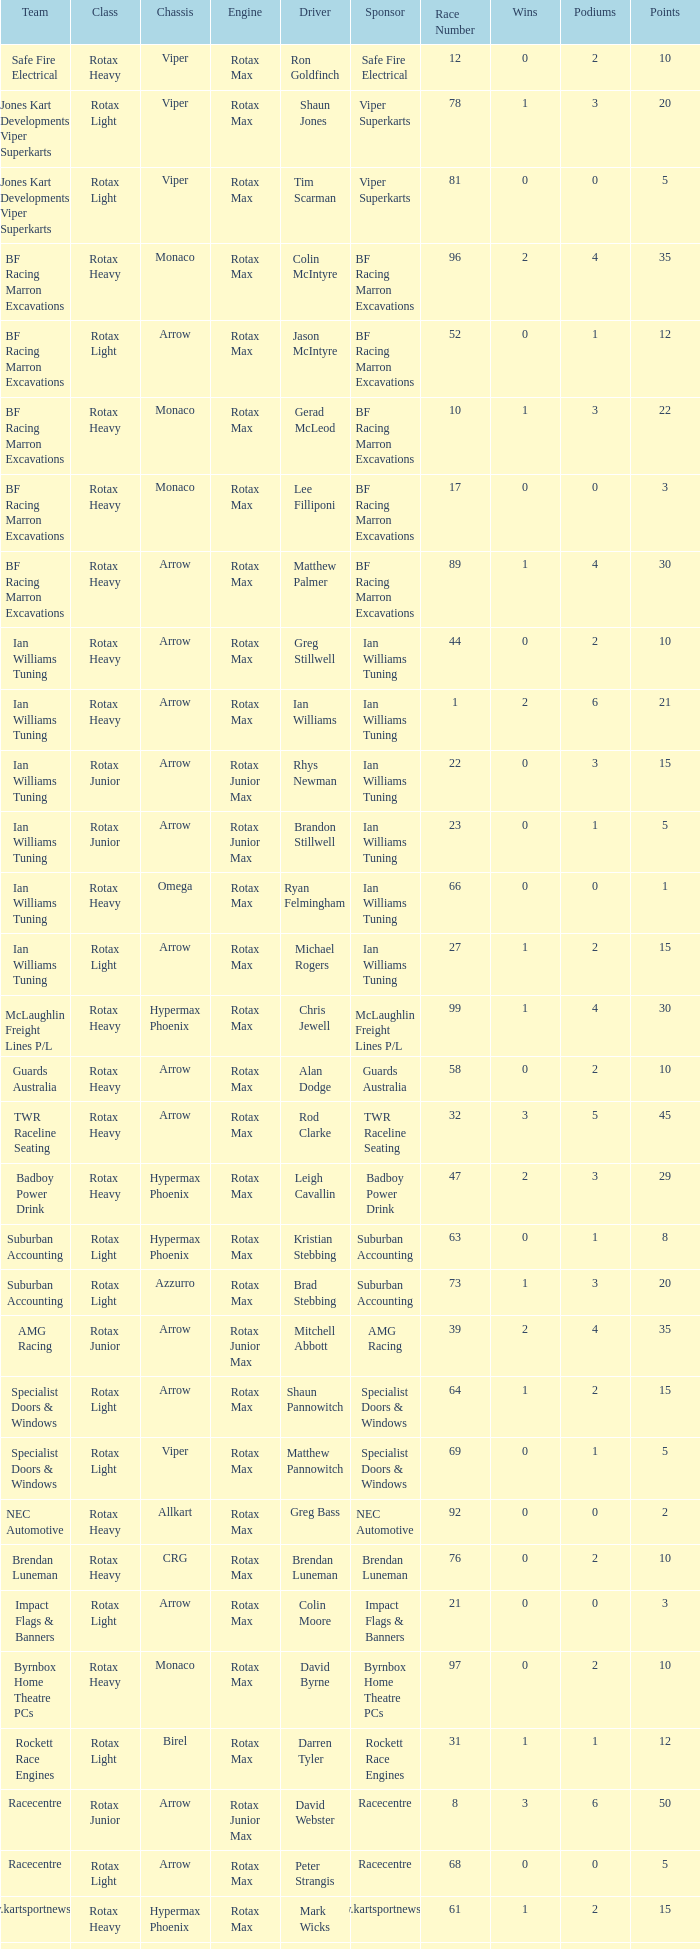Which team does Colin Moore drive for? Impact Flags & Banners. 